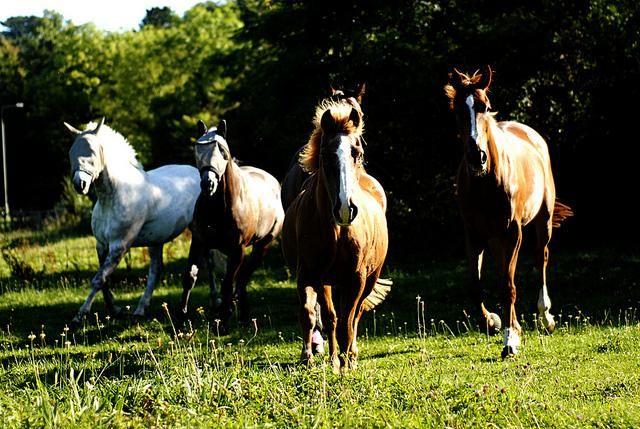These animals are known to do what? Please explain your reasoning. gallop. The horses gallop. 